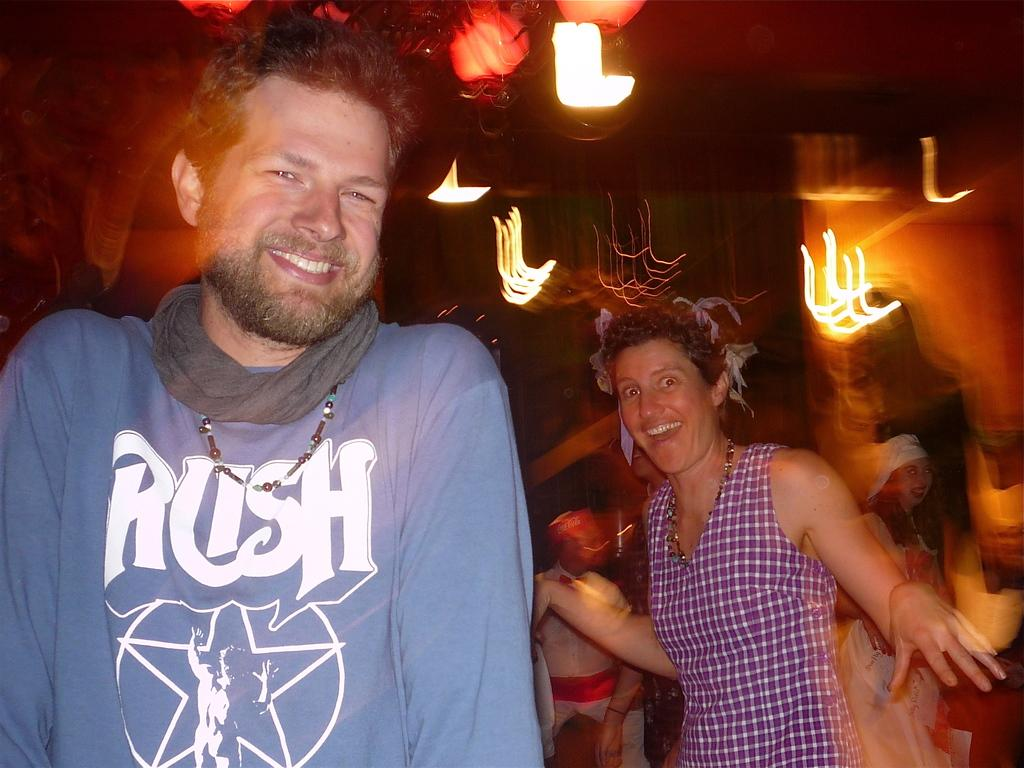How many people are present in the image? There are two people, a man and a woman, present in the image. What are the man and woman doing in the image? The man and woman are standing. What can be seen in the background of the image? There are people and lights visible in the background of the image. What degree does the woman have in teaching, as mentioned in the image? There is no mention of degrees or teaching in the image; it simply shows a man and a woman standing. 